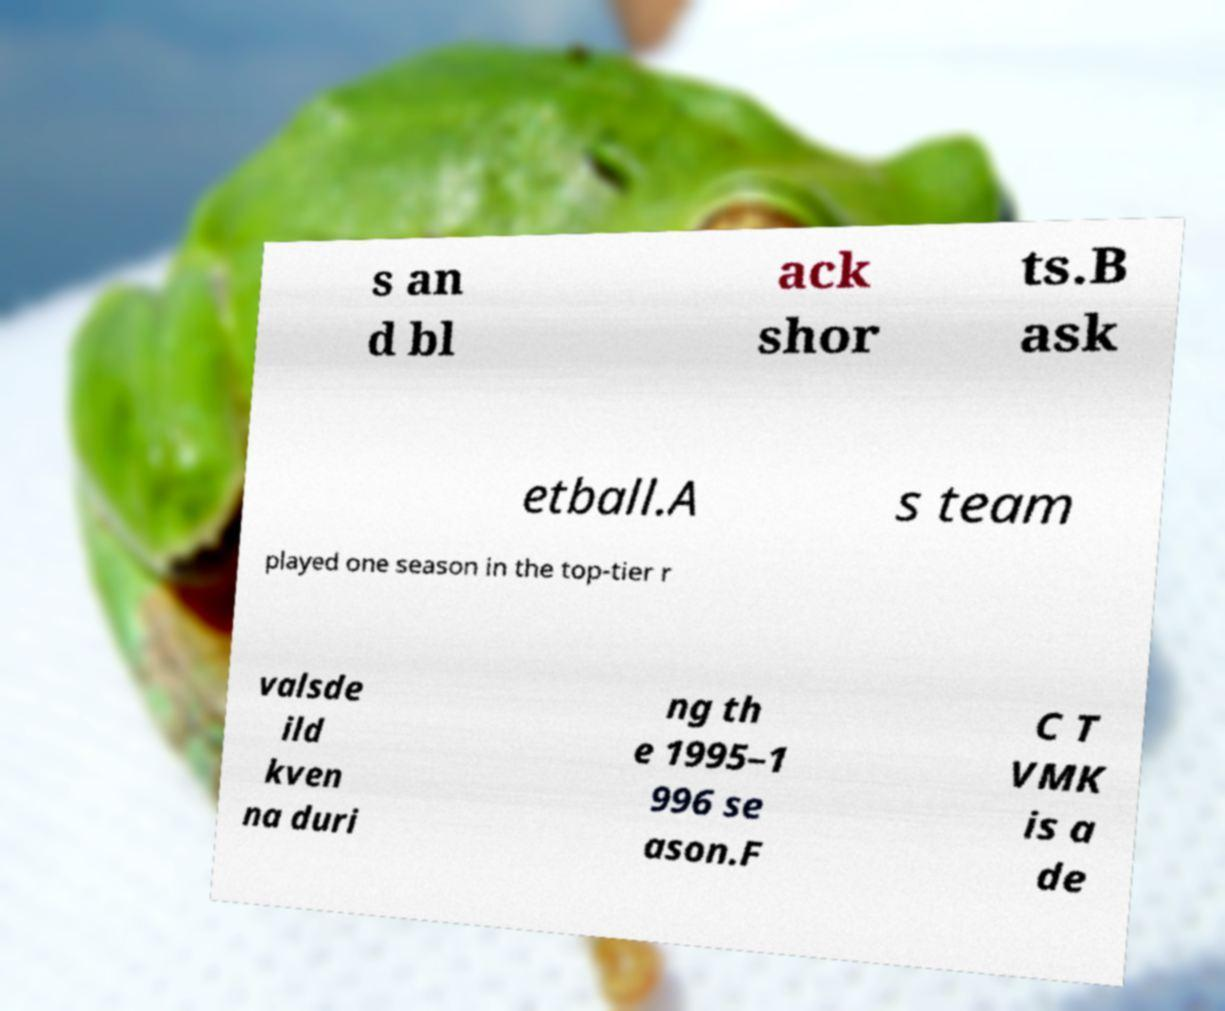For documentation purposes, I need the text within this image transcribed. Could you provide that? s an d bl ack shor ts.B ask etball.A s team played one season in the top-tier r valsde ild kven na duri ng th e 1995–1 996 se ason.F C T VMK is a de 